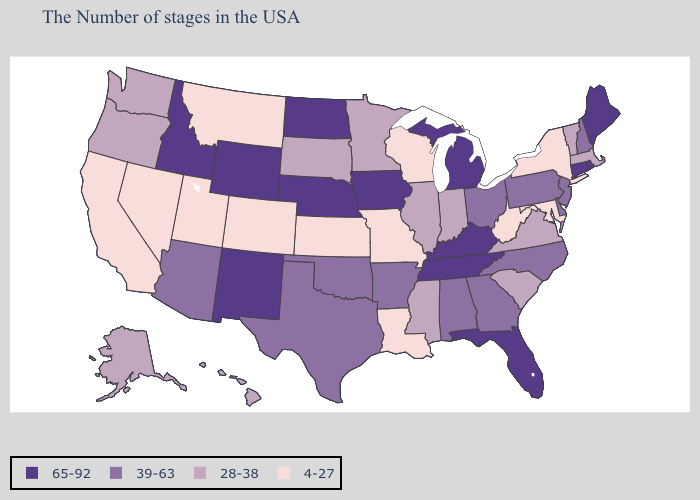Does Mississippi have a higher value than Iowa?
Answer briefly. No. Name the states that have a value in the range 39-63?
Quick response, please. New Hampshire, New Jersey, Delaware, Pennsylvania, North Carolina, Ohio, Georgia, Alabama, Arkansas, Oklahoma, Texas, Arizona. What is the value of Maryland?
Answer briefly. 4-27. Does North Dakota have the highest value in the USA?
Concise answer only. Yes. Among the states that border Ohio , does Indiana have the lowest value?
Quick response, please. No. Name the states that have a value in the range 39-63?
Short answer required. New Hampshire, New Jersey, Delaware, Pennsylvania, North Carolina, Ohio, Georgia, Alabama, Arkansas, Oklahoma, Texas, Arizona. Does the map have missing data?
Answer briefly. No. Among the states that border Montana , which have the lowest value?
Short answer required. South Dakota. What is the highest value in states that border Oregon?
Answer briefly. 65-92. Does Florida have a higher value than Arkansas?
Concise answer only. Yes. What is the value of New Mexico?
Keep it brief. 65-92. Does Nebraska have the highest value in the USA?
Be succinct. Yes. Name the states that have a value in the range 28-38?
Short answer required. Massachusetts, Vermont, Virginia, South Carolina, Indiana, Illinois, Mississippi, Minnesota, South Dakota, Washington, Oregon, Alaska, Hawaii. Name the states that have a value in the range 39-63?
Answer briefly. New Hampshire, New Jersey, Delaware, Pennsylvania, North Carolina, Ohio, Georgia, Alabama, Arkansas, Oklahoma, Texas, Arizona. What is the lowest value in states that border Florida?
Give a very brief answer. 39-63. 